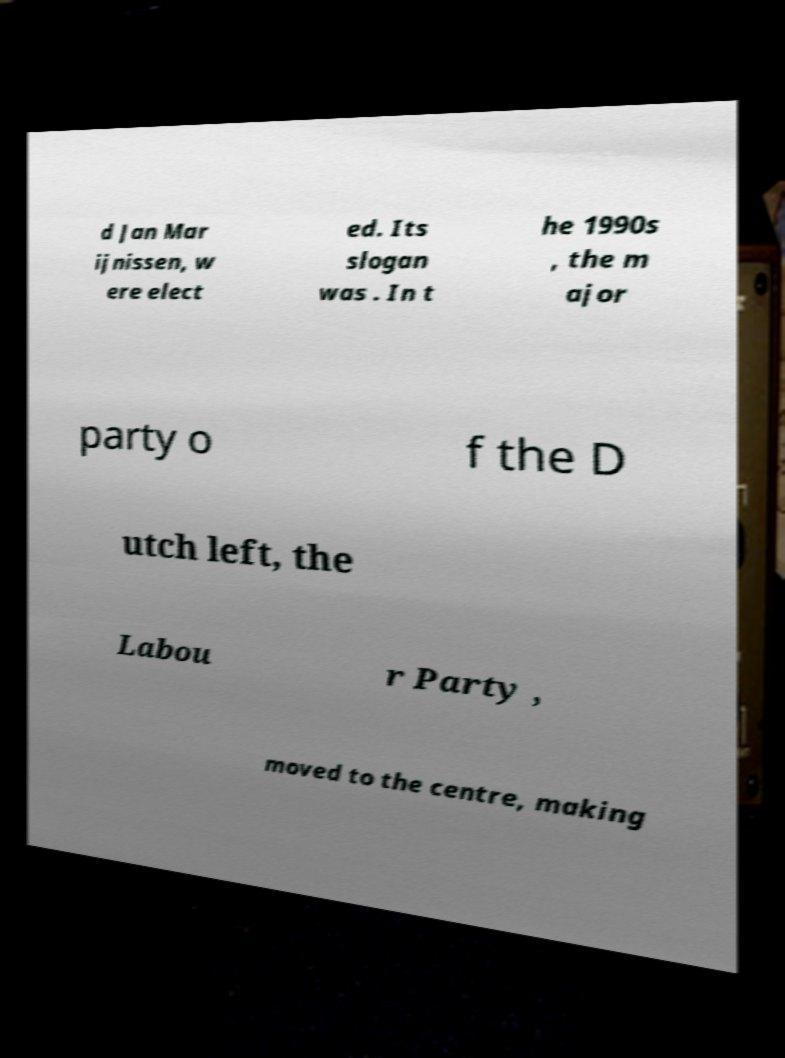What messages or text are displayed in this image? I need them in a readable, typed format. d Jan Mar ijnissen, w ere elect ed. Its slogan was . In t he 1990s , the m ajor party o f the D utch left, the Labou r Party , moved to the centre, making 